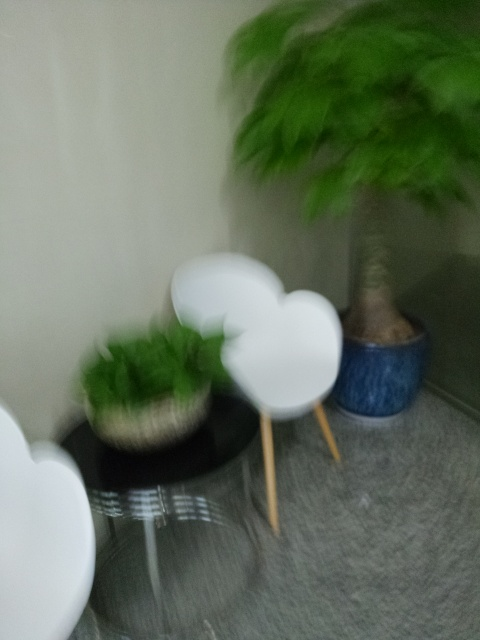Can you describe the setting of this image? The setting seems to be an indoor space, possibly within a home or an office lobby. There's a green plant present and what appears to be a round side table, all resting on a multi-tone, grayish flooring which suggests a contemporary design aesthetic. 